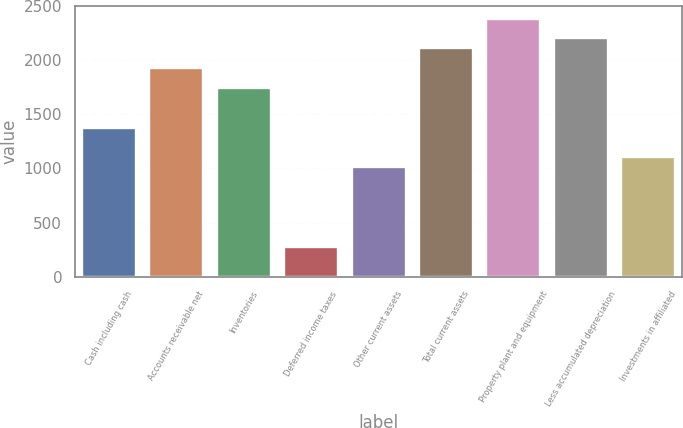Convert chart to OTSL. <chart><loc_0><loc_0><loc_500><loc_500><bar_chart><fcel>Cash including cash<fcel>Accounts receivable net<fcel>Inventories<fcel>Deferred income taxes<fcel>Other current assets<fcel>Total current assets<fcel>Property plant and equipment<fcel>Less accumulated depreciation<fcel>Investments in affiliated<nl><fcel>1377.05<fcel>1927.67<fcel>1744.13<fcel>275.81<fcel>1009.97<fcel>2111.21<fcel>2386.52<fcel>2202.98<fcel>1101.74<nl></chart> 